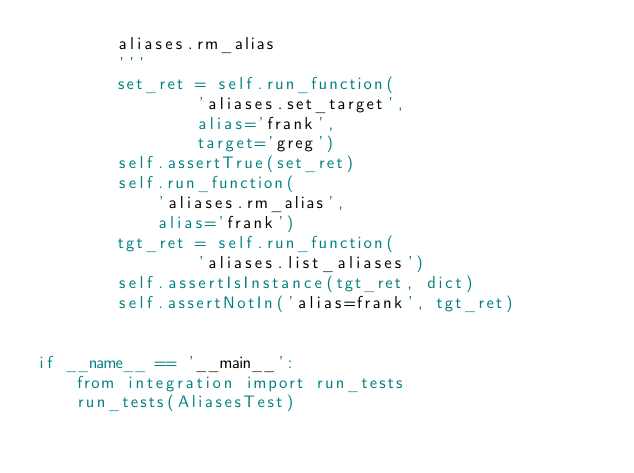<code> <loc_0><loc_0><loc_500><loc_500><_Python_>        aliases.rm_alias
        '''
        set_ret = self.run_function(
                'aliases.set_target',
                alias='frank',
                target='greg')
        self.assertTrue(set_ret)
        self.run_function(
            'aliases.rm_alias',
            alias='frank')
        tgt_ret = self.run_function(
                'aliases.list_aliases')
        self.assertIsInstance(tgt_ret, dict)
        self.assertNotIn('alias=frank', tgt_ret)


if __name__ == '__main__':
    from integration import run_tests
    run_tests(AliasesTest)
</code> 